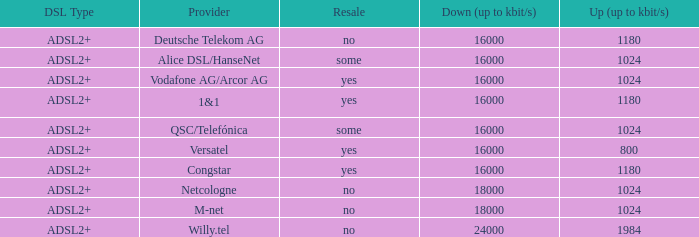What is the resale category for the provider NetCologne? No. 